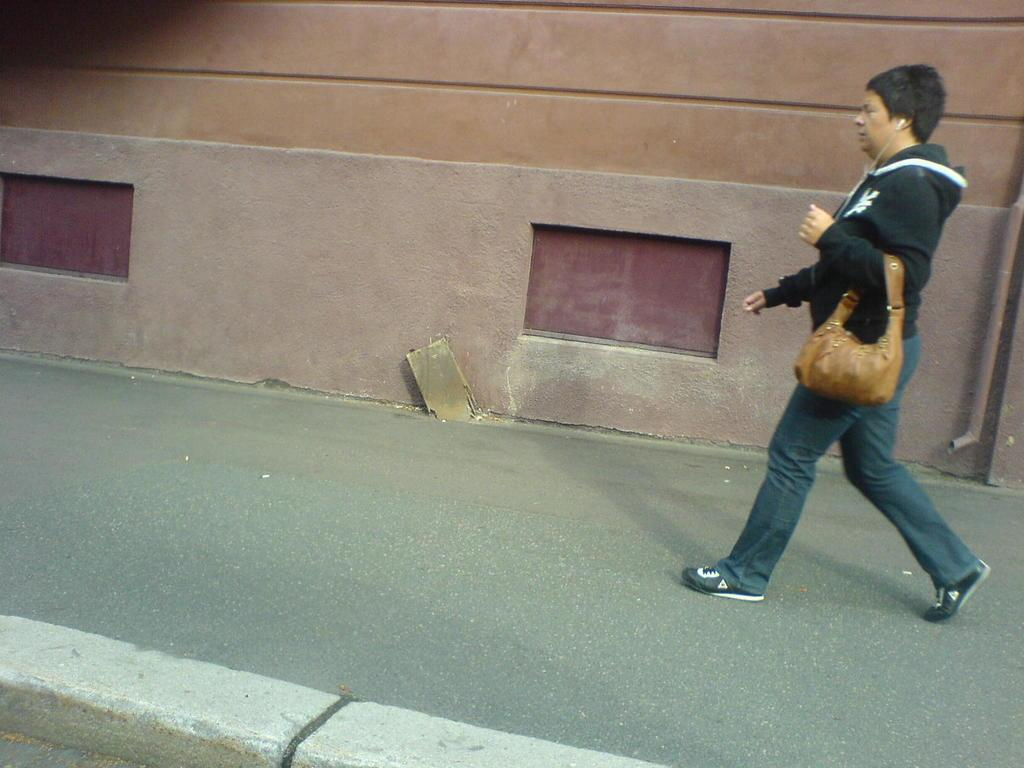Who is the main subject in the image? There is a woman in the image. What is the woman doing in the image? The woman is walking on a walkway. What is the woman carrying in the image? The woman is wearing a handbag. What might the woman be listening to in the image? The woman has earphones, so she might be listening to music or a podcast. What can be seen in the background of the image? There is a building in the background of the image. Where is the meeting taking place in the image? There is no meeting taking place in the image; it simply shows a woman walking on a walkway. 